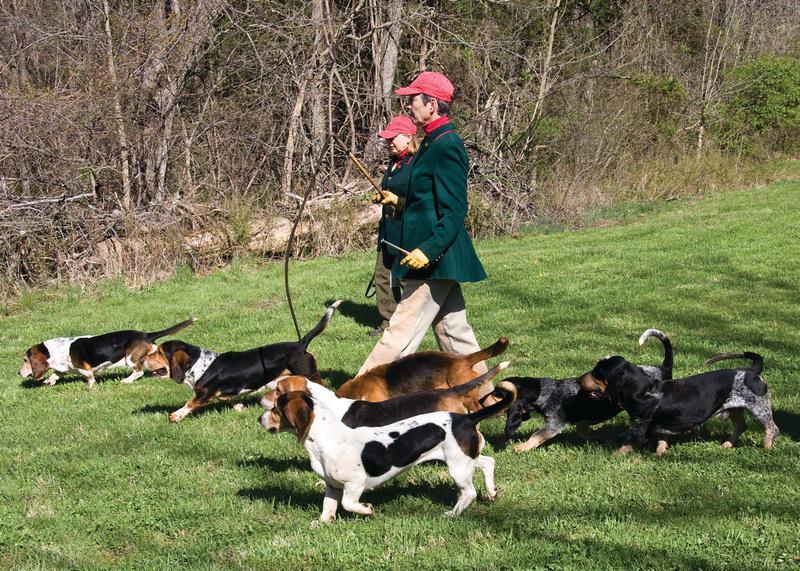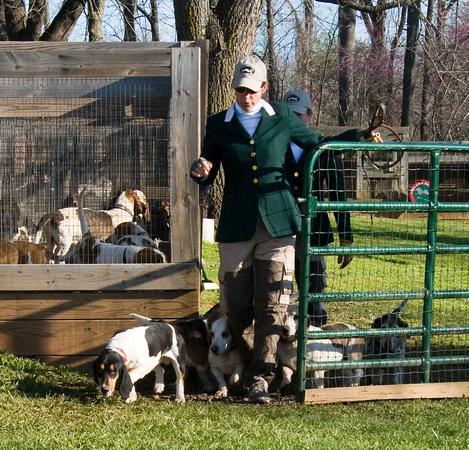The first image is the image on the left, the second image is the image on the right. Analyze the images presented: Is the assertion "An image shows a person in a green jacket holding a whip and walking leftward with a pack of dogs." valid? Answer yes or no. Yes. 